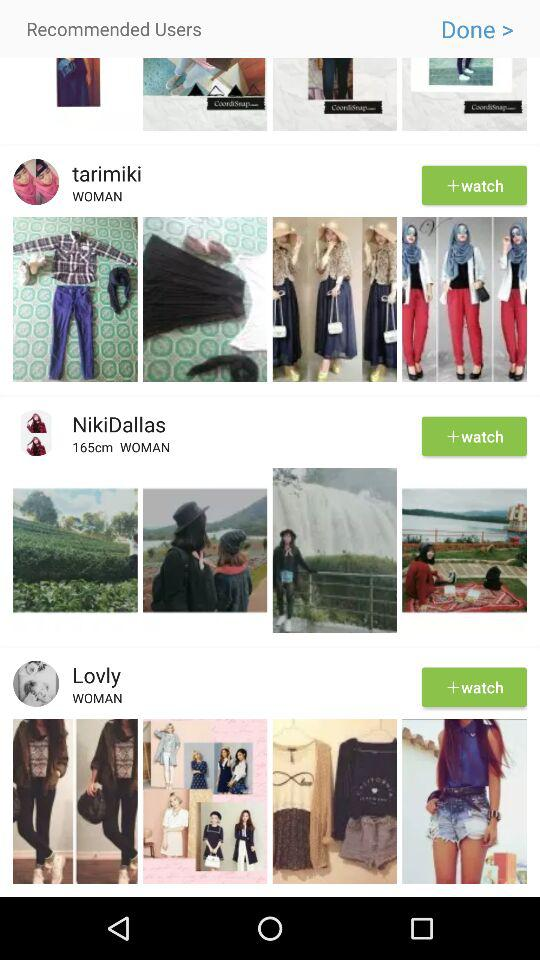What is the height of "NikiDallas"? The height of "NikiDallas" is 165 cm. 